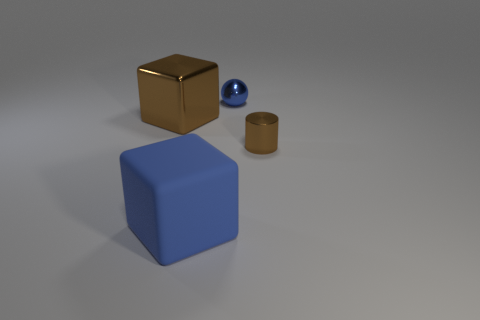What shapes are visible in the image? The image contains a variety of shapes, including two cubes, one blue and one brown, as well as a smaller sphere and a cylinder. 